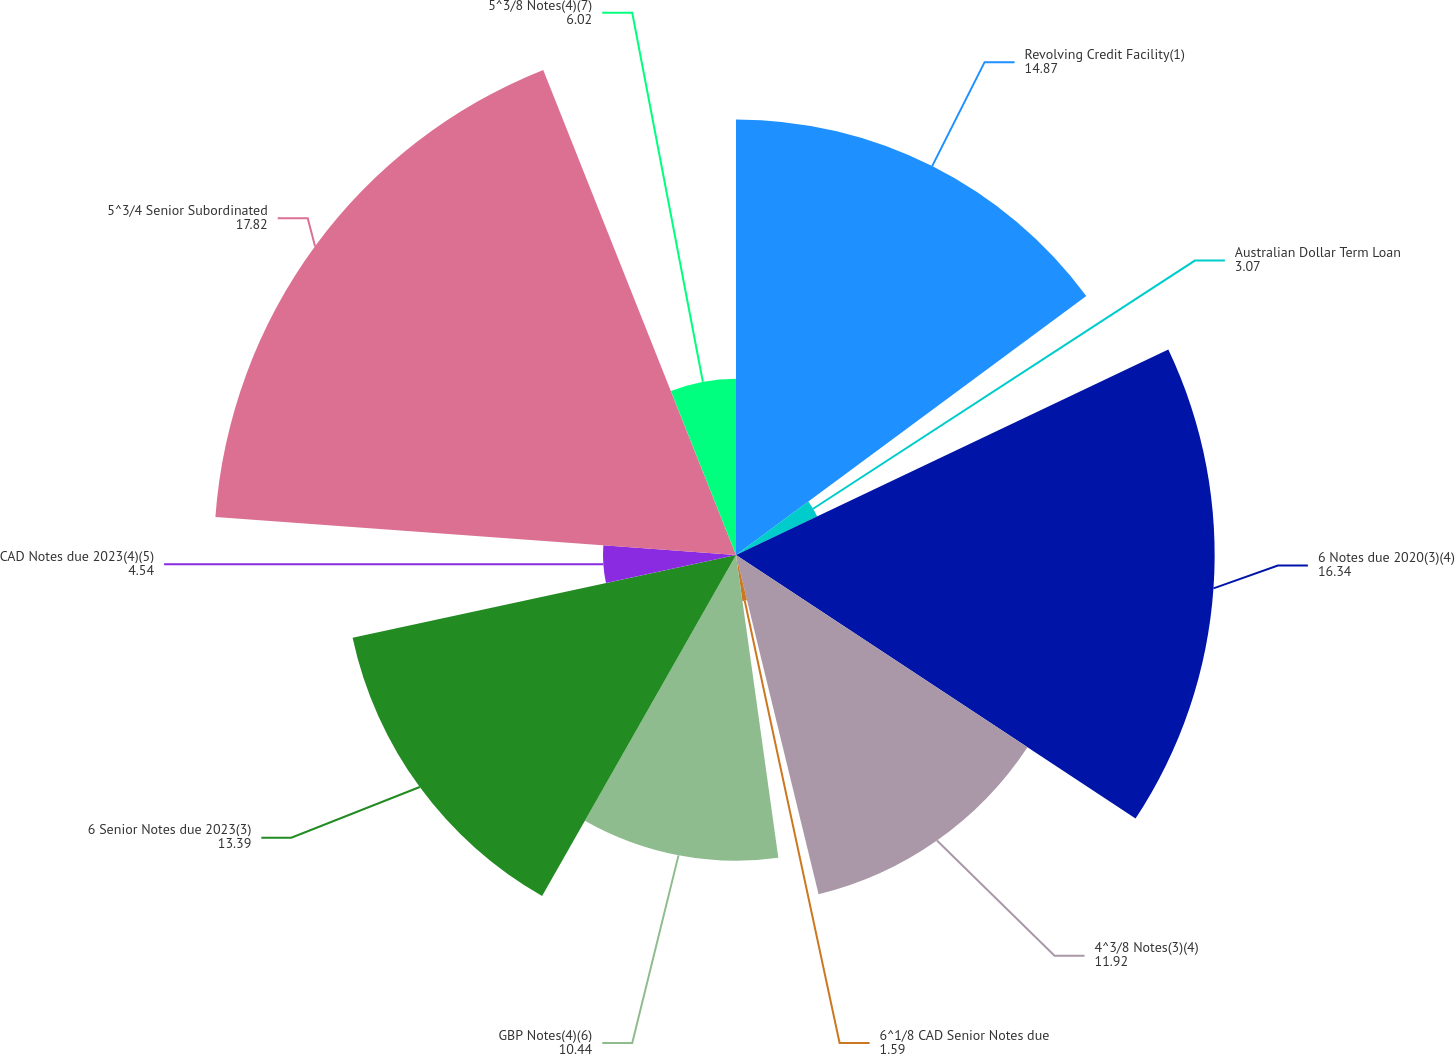Convert chart. <chart><loc_0><loc_0><loc_500><loc_500><pie_chart><fcel>Revolving Credit Facility(1)<fcel>Australian Dollar Term Loan<fcel>6 Notes due 2020(3)(4)<fcel>4^3/8 Notes(3)(4)<fcel>6^1/8 CAD Senior Notes due<fcel>GBP Notes(4)(6)<fcel>6 Senior Notes due 2023(3)<fcel>CAD Notes due 2023(4)(5)<fcel>5^3/4 Senior Subordinated<fcel>5^3/8 Notes(4)(7)<nl><fcel>14.87%<fcel>3.07%<fcel>16.34%<fcel>11.92%<fcel>1.59%<fcel>10.44%<fcel>13.39%<fcel>4.54%<fcel>17.82%<fcel>6.02%<nl></chart> 